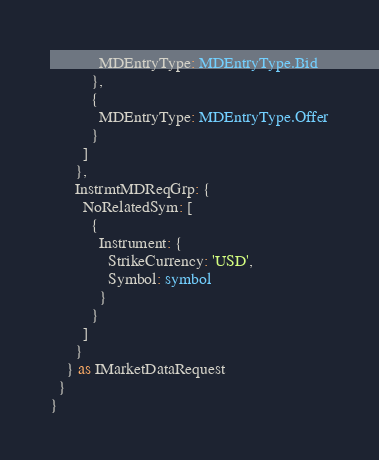<code> <loc_0><loc_0><loc_500><loc_500><_TypeScript_>            MDEntryType: MDEntryType.Bid
          },
          {
            MDEntryType: MDEntryType.Offer
          }
        ]
      },
      InstrmtMDReqGrp: {
        NoRelatedSym: [
          {
            Instrument: {
              StrikeCurrency: 'USD',
              Symbol: symbol
            }
          }
        ]
      }
    } as IMarketDataRequest
  }
}
</code> 